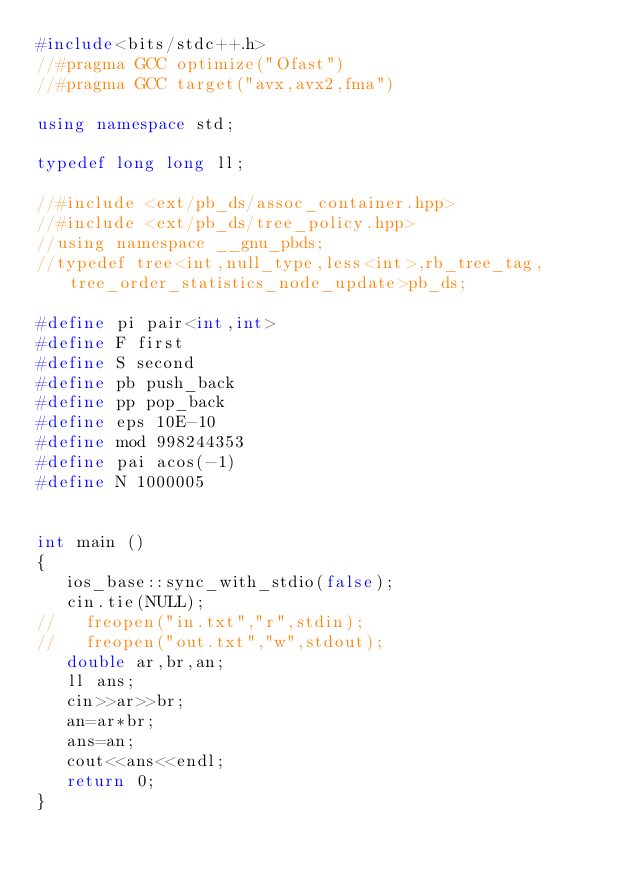<code> <loc_0><loc_0><loc_500><loc_500><_C++_>#include<bits/stdc++.h>
//#pragma GCC optimize("Ofast")
//#pragma GCC target("avx,avx2,fma")

using namespace std;

typedef long long ll;

//#include <ext/pb_ds/assoc_container.hpp>
//#include <ext/pb_ds/tree_policy.hpp>
//using namespace __gnu_pbds;
//typedef tree<int,null_type,less<int>,rb_tree_tag,tree_order_statistics_node_update>pb_ds;

#define pi pair<int,int>
#define F first
#define S second
#define pb push_back
#define pp pop_back
#define eps 10E-10
#define mod 998244353
#define pai acos(-1)
#define N 1000005


int main ()
{
   ios_base::sync_with_stdio(false);
   cin.tie(NULL);
//   freopen("in.txt","r",stdin);
//   freopen("out.txt","w",stdout);
   double ar,br,an;
   ll ans;
   cin>>ar>>br;
   an=ar*br;
   ans=an;
   cout<<ans<<endl;
   return 0;
}
</code> 